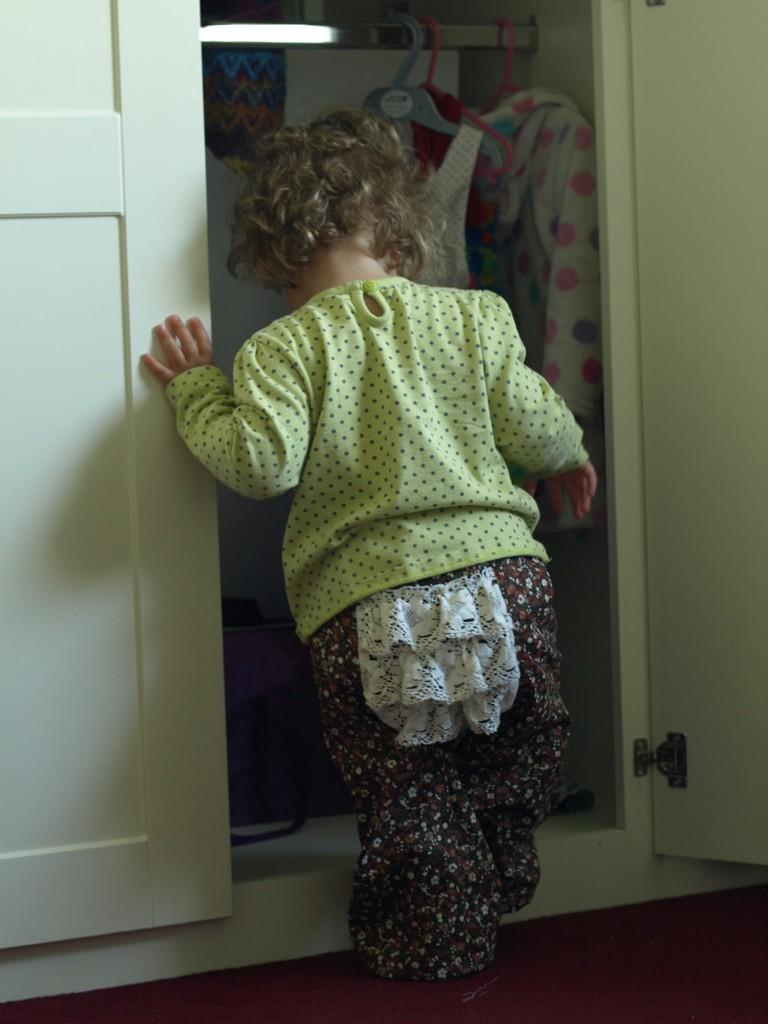What is the main subject of the image? There is a baby in the image. What is the baby doing in the image? The baby is walking and touching the door. Are there any objects related to clothing in the image? Yes, there are clothes in the image, and they are on a hanger. What type of glue is the baby using to stick the clothes on the hanger? There is no glue present in the image, and the baby is not using any glue to stick the clothes on the hanger. Does the baby have a brother in the image? The provided facts do not mention the presence of a brother, so we cannot determine if the baby has a brother in the image. 